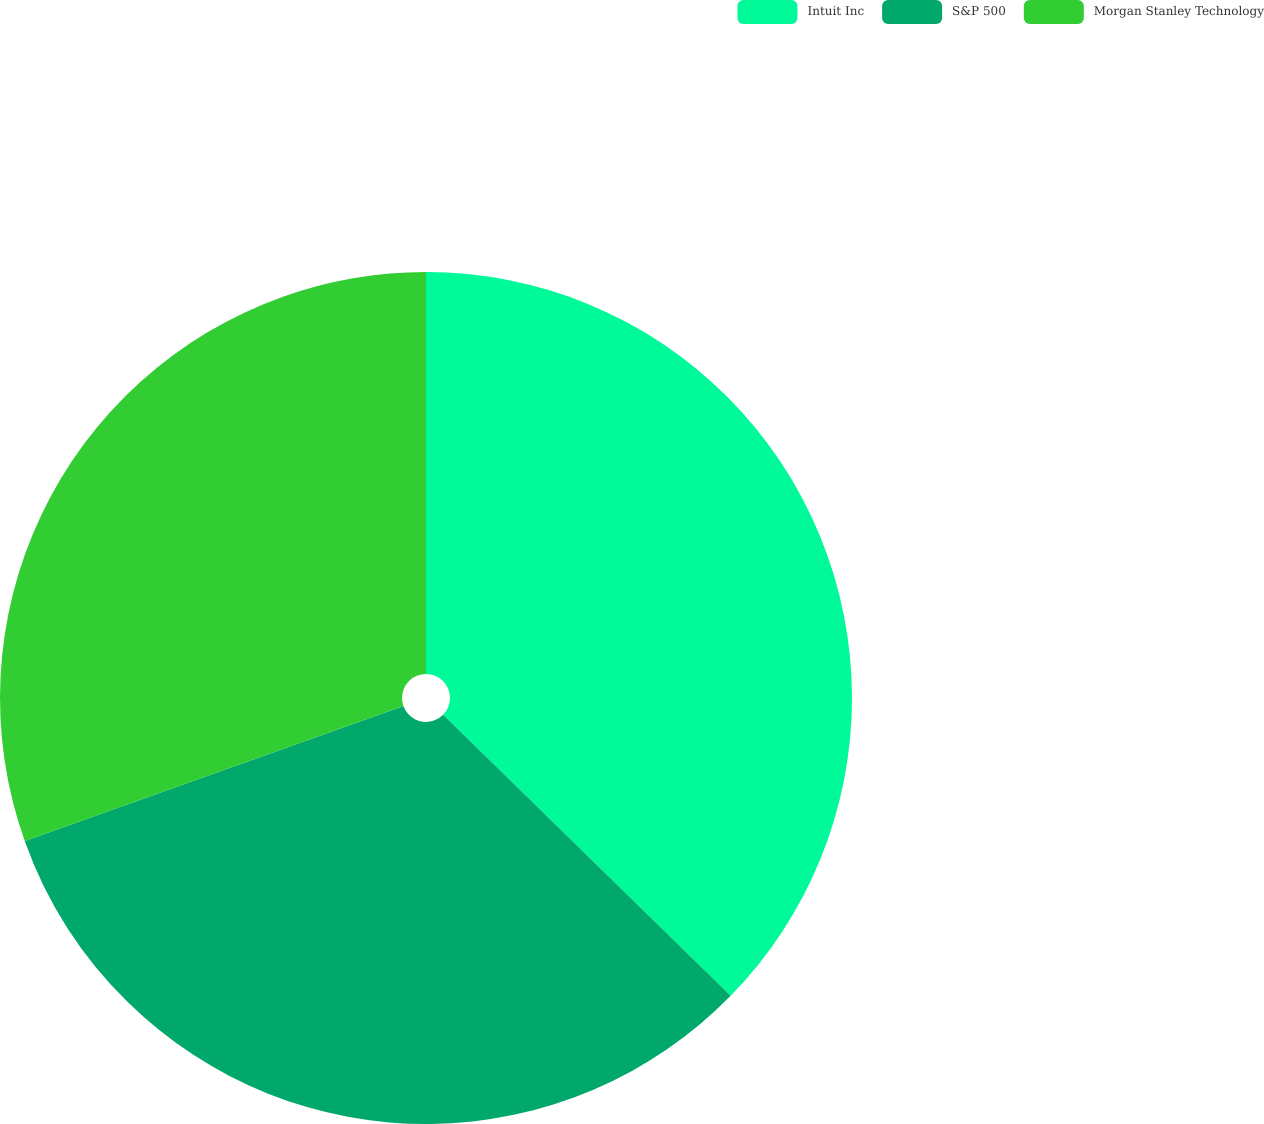<chart> <loc_0><loc_0><loc_500><loc_500><pie_chart><fcel>Intuit Inc<fcel>S&P 500<fcel>Morgan Stanley Technology<nl><fcel>37.32%<fcel>32.23%<fcel>30.45%<nl></chart> 